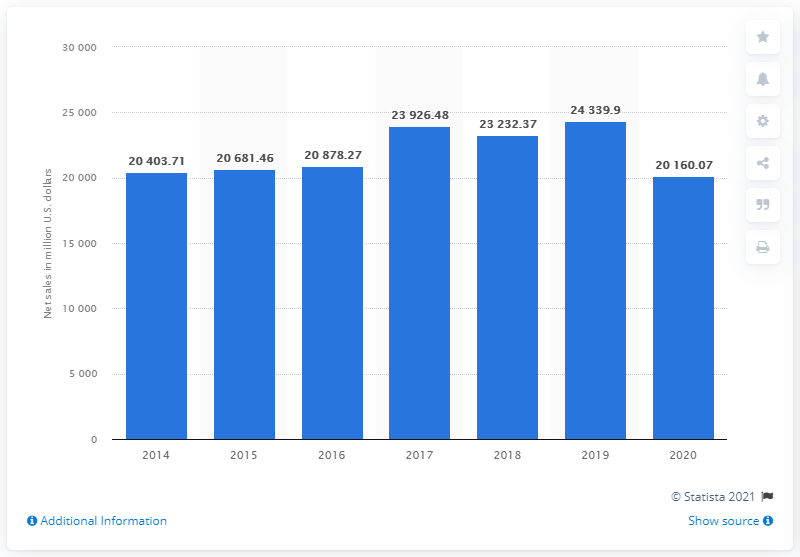Point out several critical features in this image. H&M's sales in 2020 were approximately 20,160.07. 